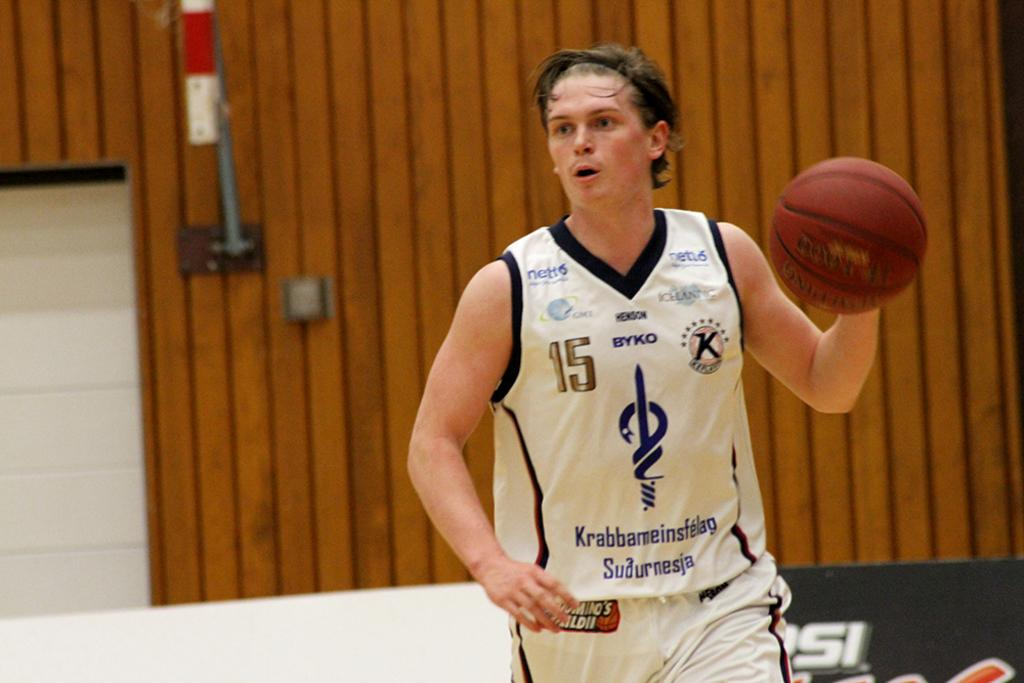<image>
Render a clear and concise summary of the photo. the number 15 is on the player's jersey 